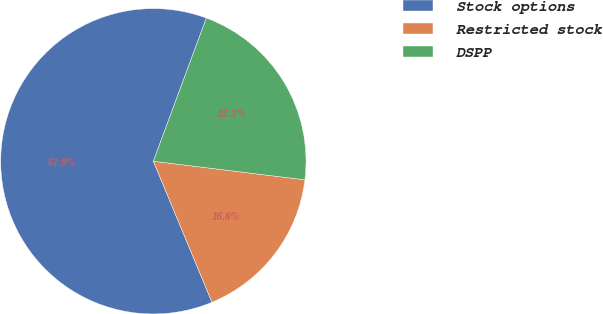Convert chart to OTSL. <chart><loc_0><loc_0><loc_500><loc_500><pie_chart><fcel>Stock options<fcel>Restricted stock<fcel>DSPP<nl><fcel>61.91%<fcel>16.79%<fcel>21.3%<nl></chart> 